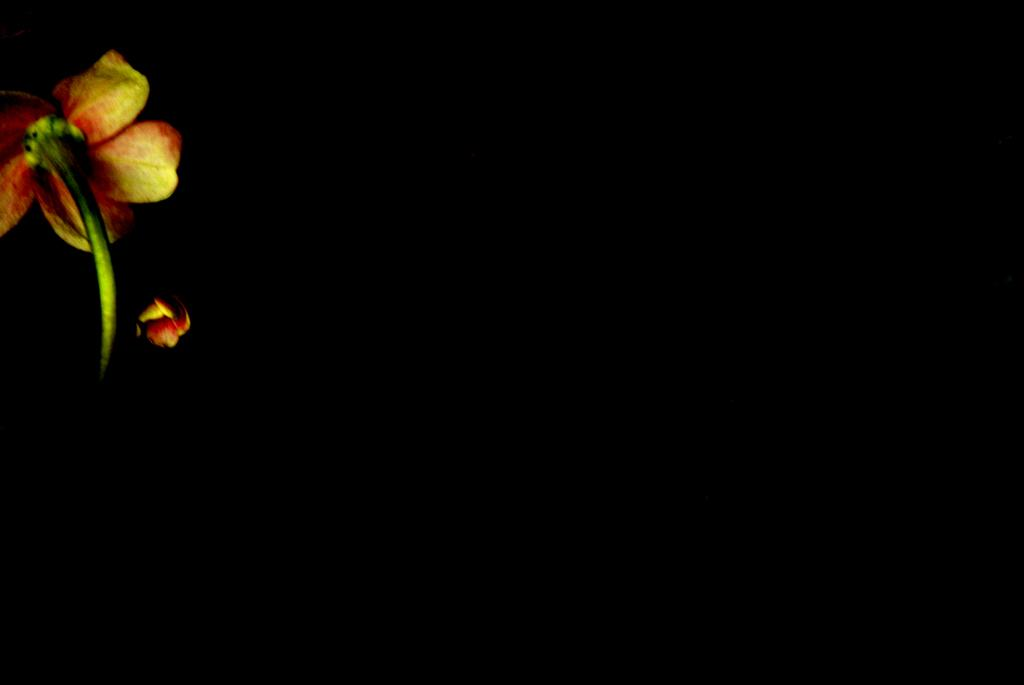What is the main subject of the image? The main subject of the image is a flower. How is the flower depicted in the image? The flower is truncated towards the left side. What can be observed about the background of the image? The background of the image is dark. How many kittens are playing with a gold vest in the image? There are no kittens or gold vests present in the image; it features a flower with a dark background. 